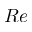Convert formula to latex. <formula><loc_0><loc_0><loc_500><loc_500>R e</formula> 